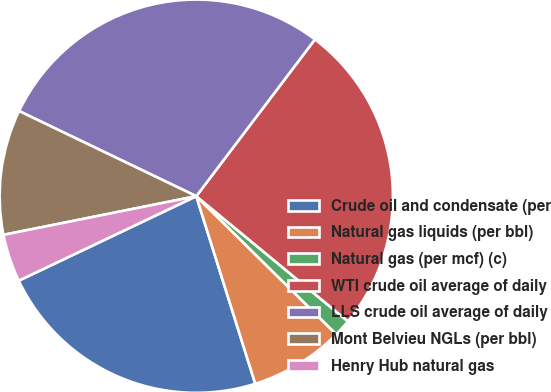Convert chart. <chart><loc_0><loc_0><loc_500><loc_500><pie_chart><fcel>Crude oil and condensate (per<fcel>Natural gas liquids (per bbl)<fcel>Natural gas (per mcf) (c)<fcel>WTI crude oil average of daily<fcel>LLS crude oil average of daily<fcel>Mont Belvieu NGLs (per bbl)<fcel>Henry Hub natural gas<nl><fcel>22.78%<fcel>7.76%<fcel>1.41%<fcel>25.67%<fcel>28.18%<fcel>10.28%<fcel>3.92%<nl></chart> 